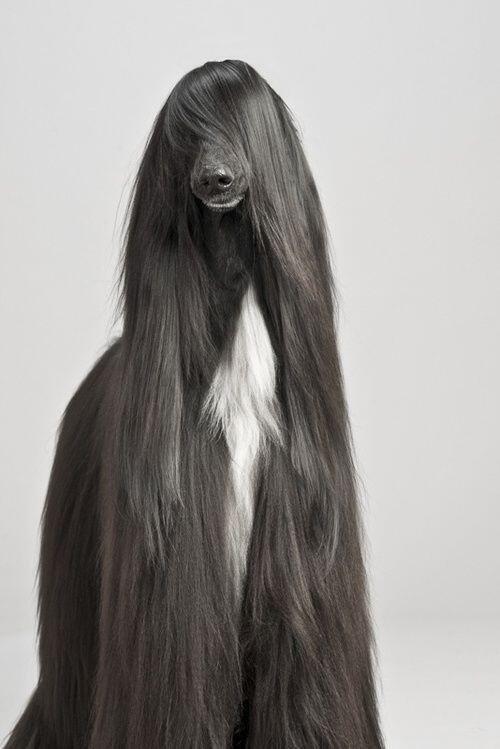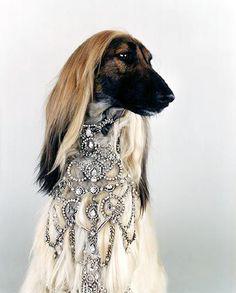The first image is the image on the left, the second image is the image on the right. Given the left and right images, does the statement "there us a dog wearing a necklace draped on it's neck" hold true? Answer yes or no. Yes. The first image is the image on the left, the second image is the image on the right. Considering the images on both sides, is "One of the dogs is wearing jewelry." valid? Answer yes or no. Yes. 